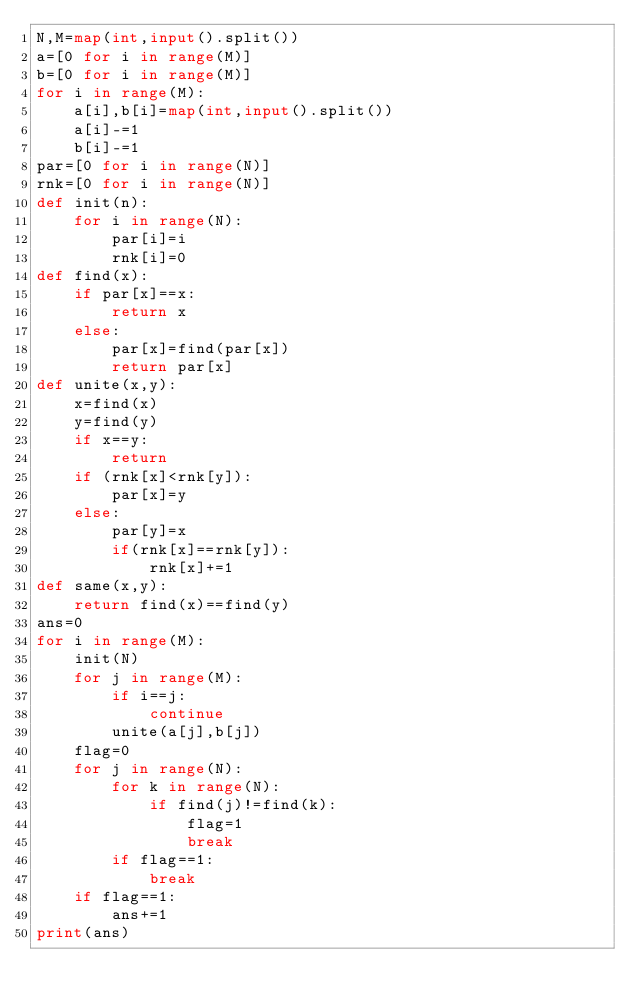Convert code to text. <code><loc_0><loc_0><loc_500><loc_500><_Python_>N,M=map(int,input().split())
a=[0 for i in range(M)]
b=[0 for i in range(M)]
for i in range(M):
    a[i],b[i]=map(int,input().split())
    a[i]-=1
    b[i]-=1
par=[0 for i in range(N)]
rnk=[0 for i in range(N)]
def init(n):
    for i in range(N):
        par[i]=i
        rnk[i]=0
def find(x):
    if par[x]==x:
        return x
    else:
        par[x]=find(par[x])
        return par[x]
def unite(x,y):
    x=find(x)
    y=find(y)
    if x==y:
        return
    if (rnk[x]<rnk[y]):
        par[x]=y
    else:
        par[y]=x
        if(rnk[x]==rnk[y]):
            rnk[x]+=1
def same(x,y):
    return find(x)==find(y)
ans=0
for i in range(M):
    init(N)
    for j in range(M):
        if i==j:
            continue
        unite(a[j],b[j])
    flag=0
    for j in range(N):
        for k in range(N):
            if find(j)!=find(k):
                flag=1
                break
        if flag==1:
            break
    if flag==1:
        ans+=1
print(ans)

</code> 